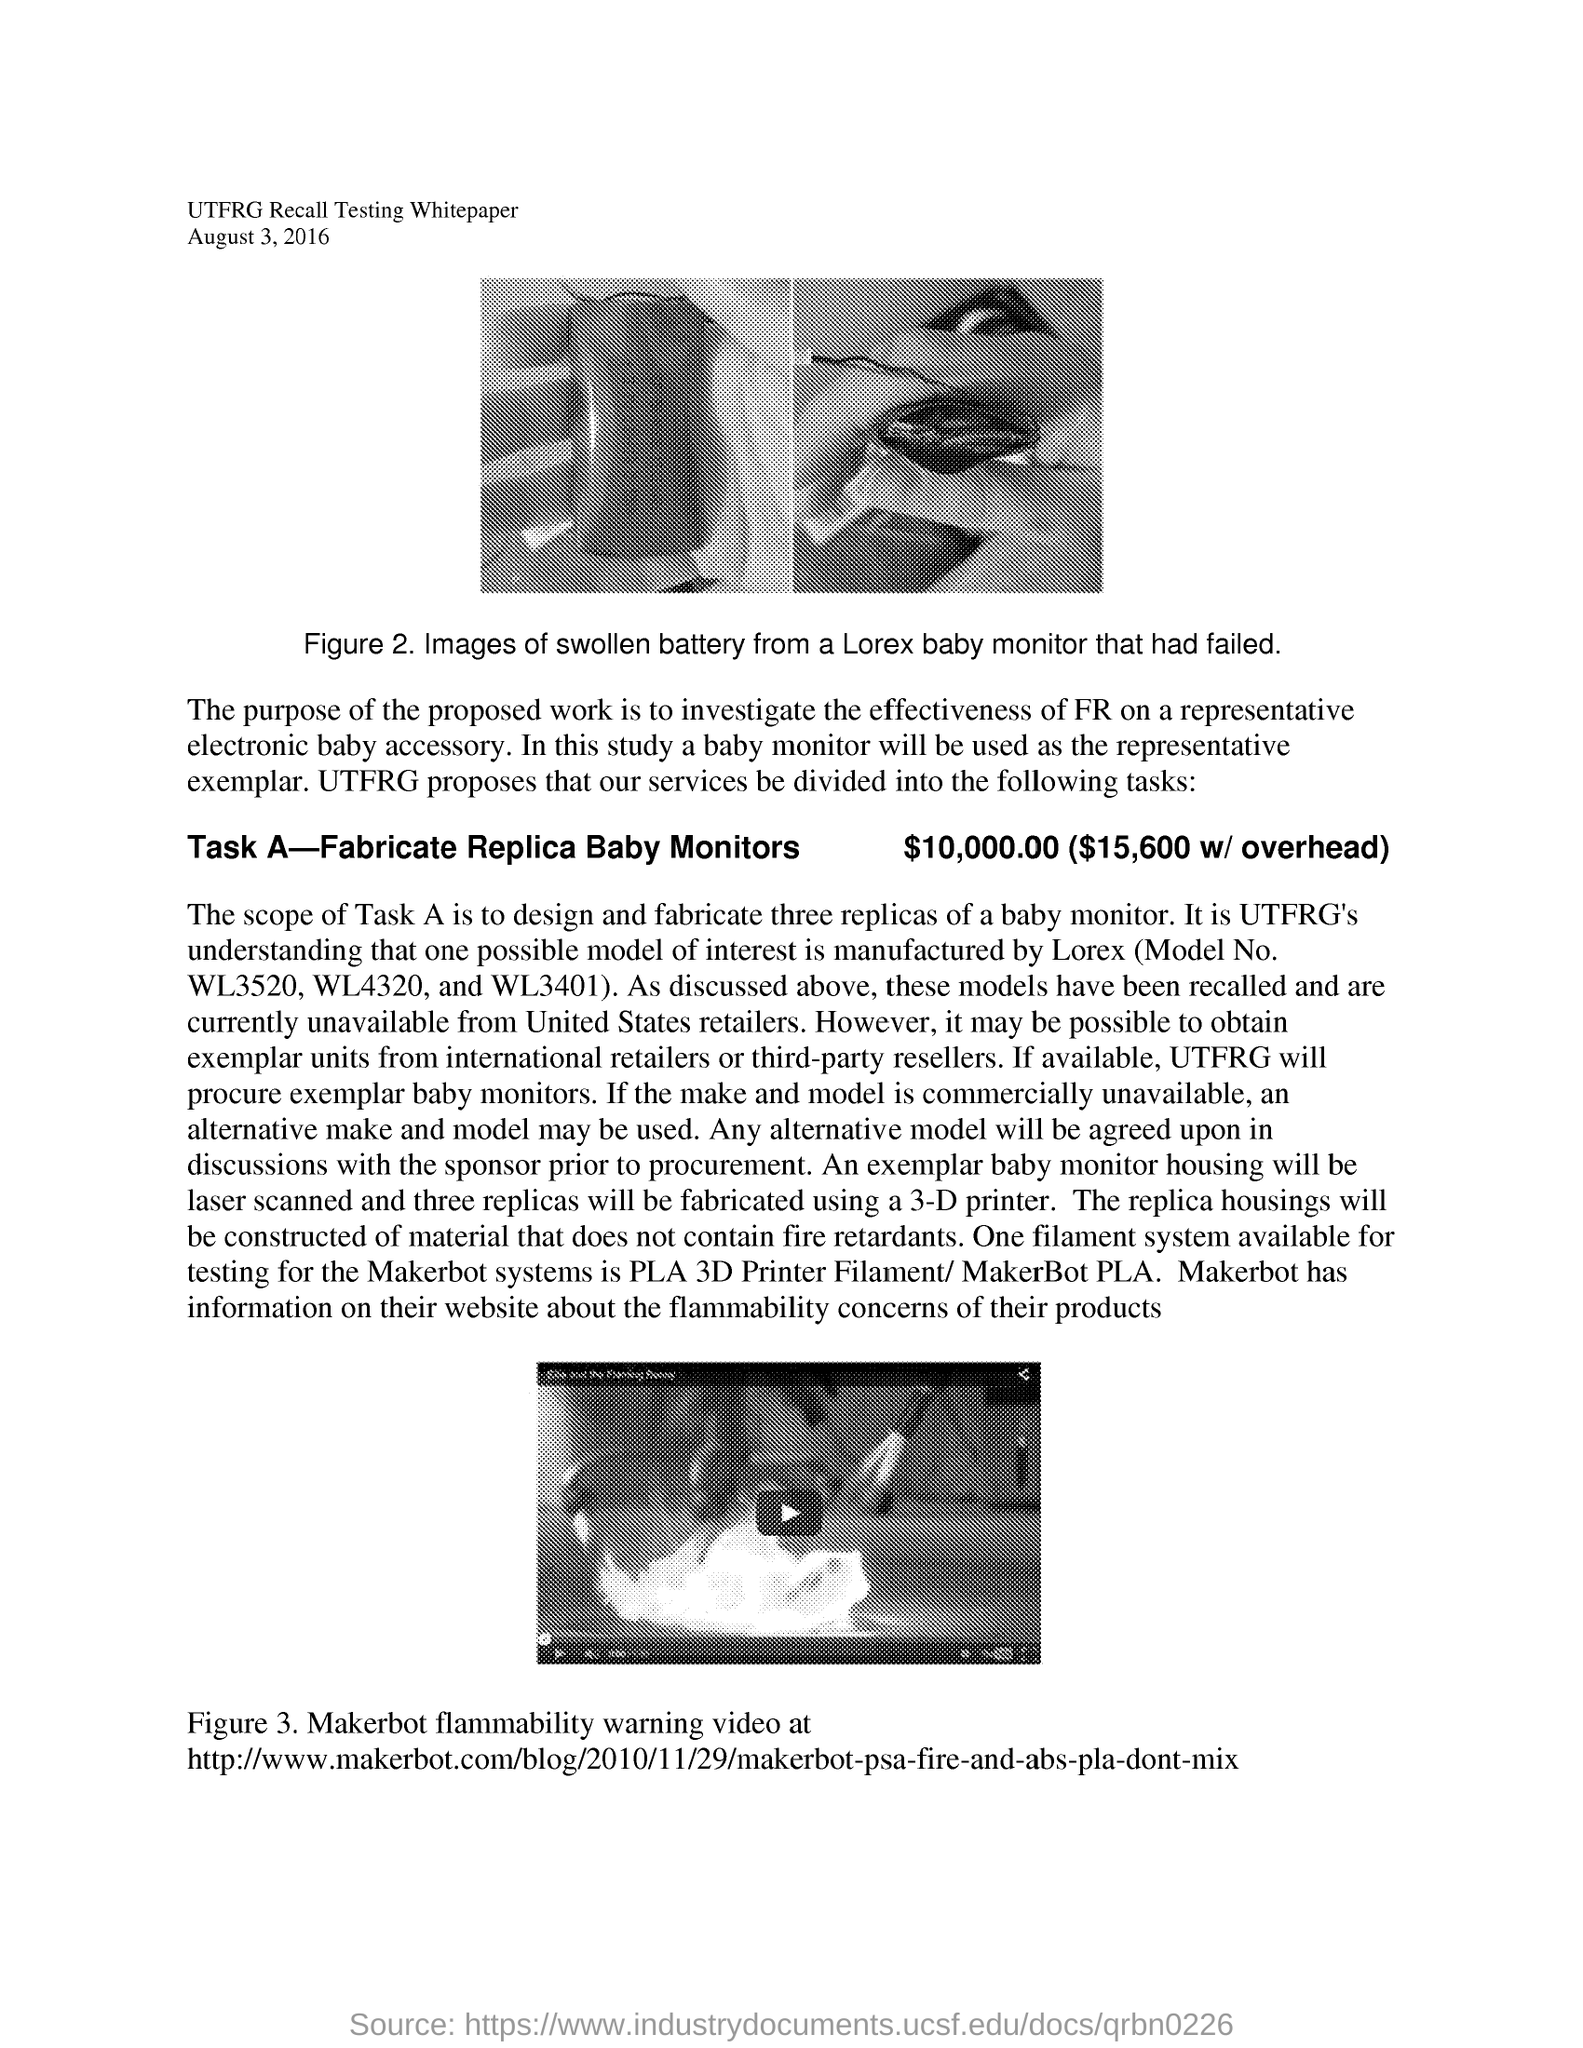What is Task A?
Provide a short and direct response. Fabricate Replica Baby Monitors. What does the Figure 3 show?
Ensure brevity in your answer.  Makerbot Flammability warning video. What is the date mentioned?
Keep it short and to the point. August 3, 2016. 